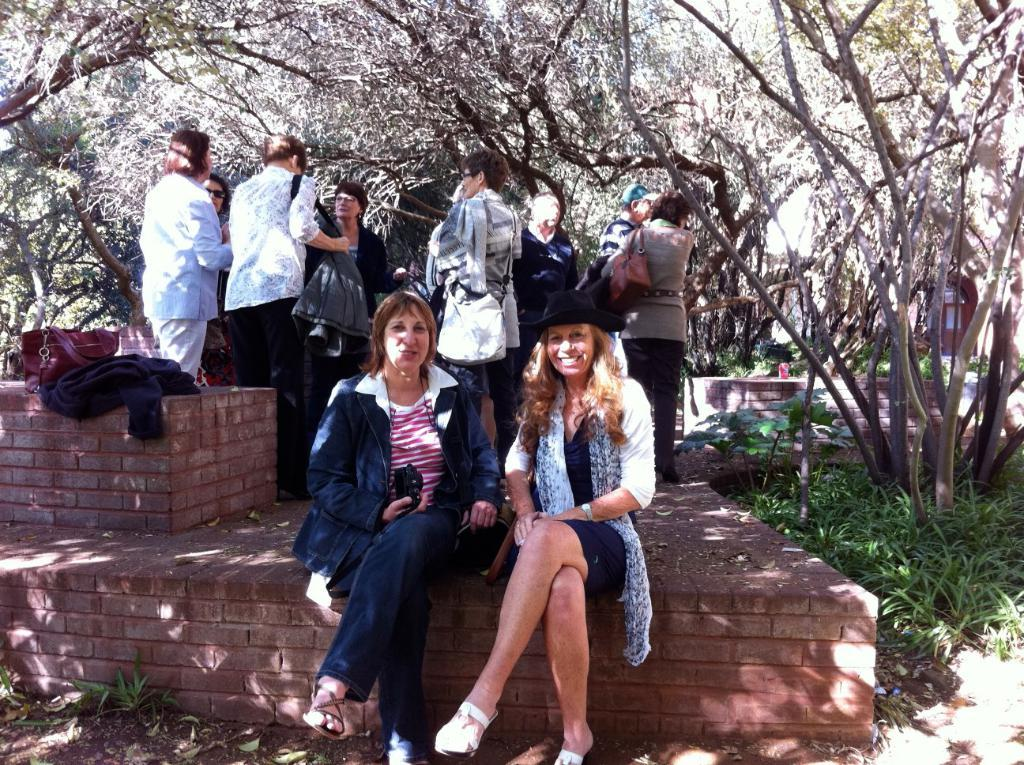How many people can be seen at the bottom of the image? There are two persons standing on a platform at the bottom of the image. What is happening to the people in the middle of the image? There are some persons standing in the middle of the image. What can be seen in the background of the image? There are trees in the background of the image. Are there any deer visible in the image? There are no deer present in the image; only people and trees can be seen. What type of railway is visible in the image? There is no railway present in the image. 